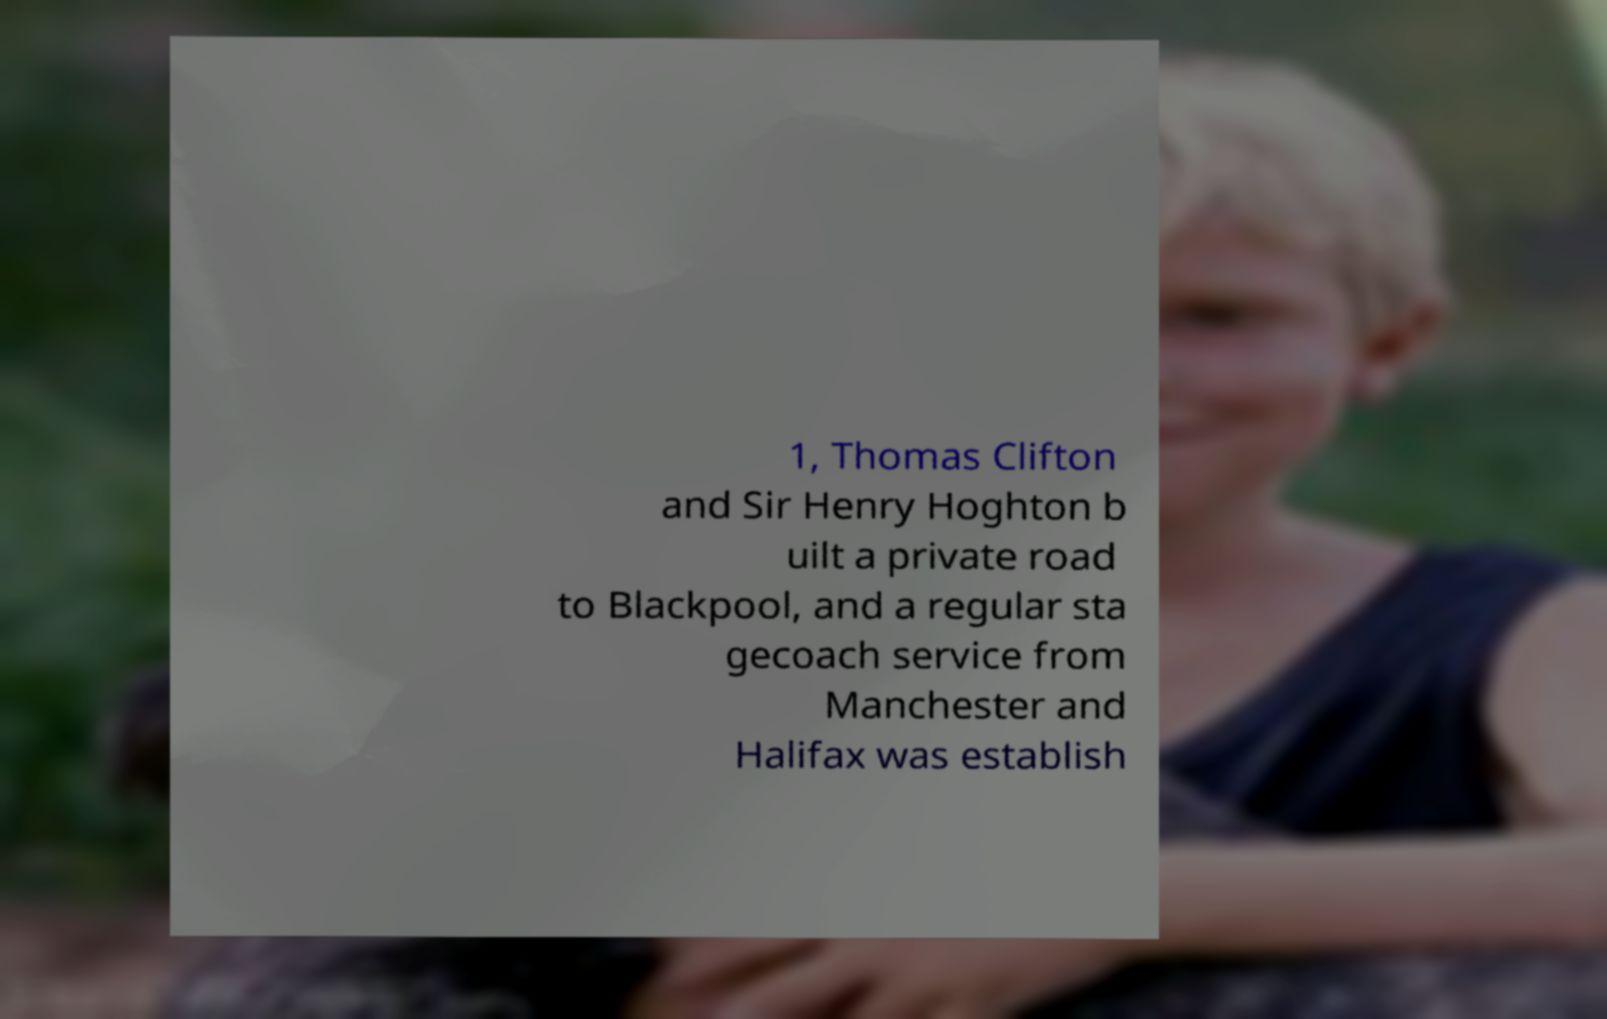What messages or text are displayed in this image? I need them in a readable, typed format. 1, Thomas Clifton and Sir Henry Hoghton b uilt a private road to Blackpool, and a regular sta gecoach service from Manchester and Halifax was establish 